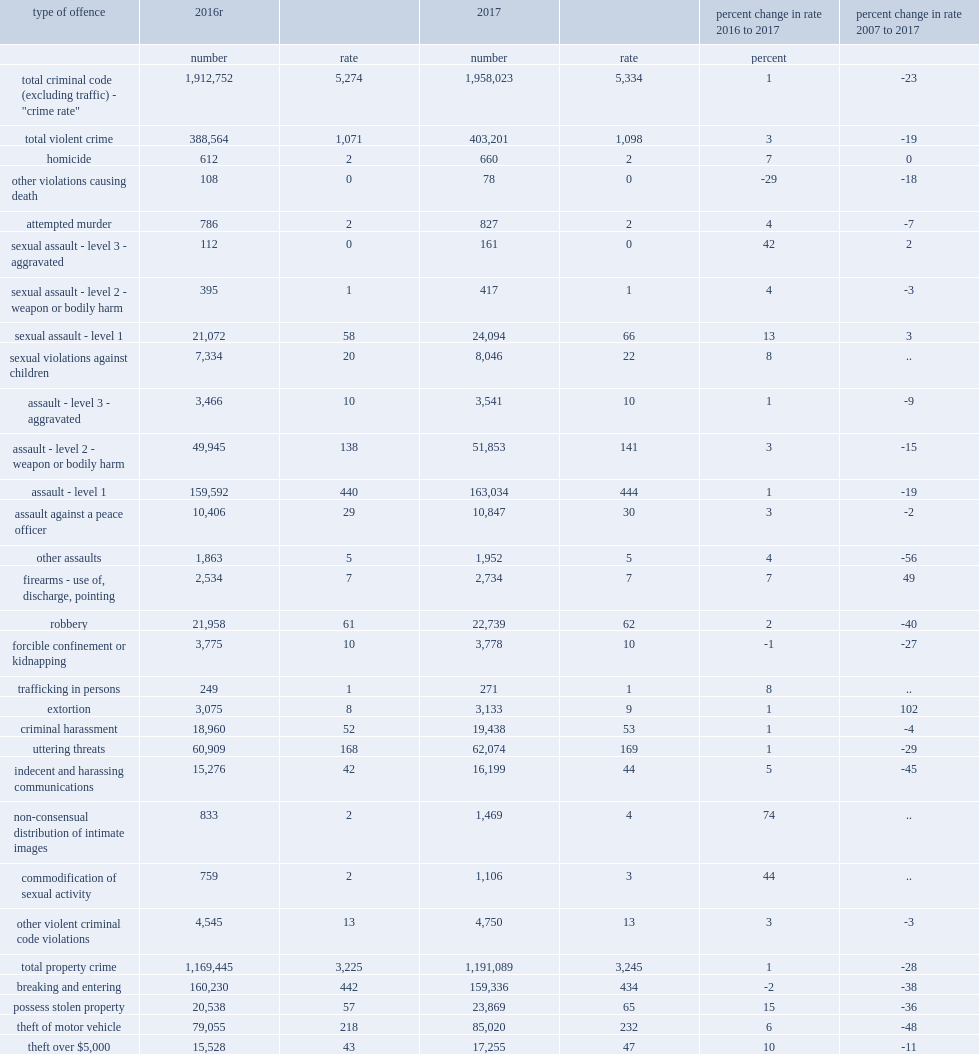What was the percent change in rate of sexual assault with a weapon or causing bodily harm from 2016 to 2017? 4.0. What was the number change in incidents of aggravated sexual assault (level 3) from 2016 to 2017? 49. What was the percent change in rate of commodification of sexual activity offences from 2016 to 2017? 44.0. What was the percent change in rate of assault with a weapon or causing bodily harm (level 2) from 2016 to 2017? 3.0. What was the percent change in rate of firearms - use of, discharge, pointing from 2016 to 2017? 7.0. What was the percent change in rate of fraud from 2016 to 2017? 2.0. What was the rate of cdsa offences reported by polic in 2017? 247.0. 